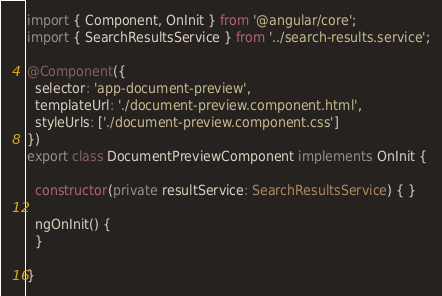<code> <loc_0><loc_0><loc_500><loc_500><_TypeScript_>import { Component, OnInit } from '@angular/core';
import { SearchResultsService } from '../search-results.service';

@Component({
  selector: 'app-document-preview',
  templateUrl: './document-preview.component.html',
  styleUrls: ['./document-preview.component.css']
})
export class DocumentPreviewComponent implements OnInit {

  constructor(private resultService: SearchResultsService) { }

  ngOnInit() {
  }

}
</code> 